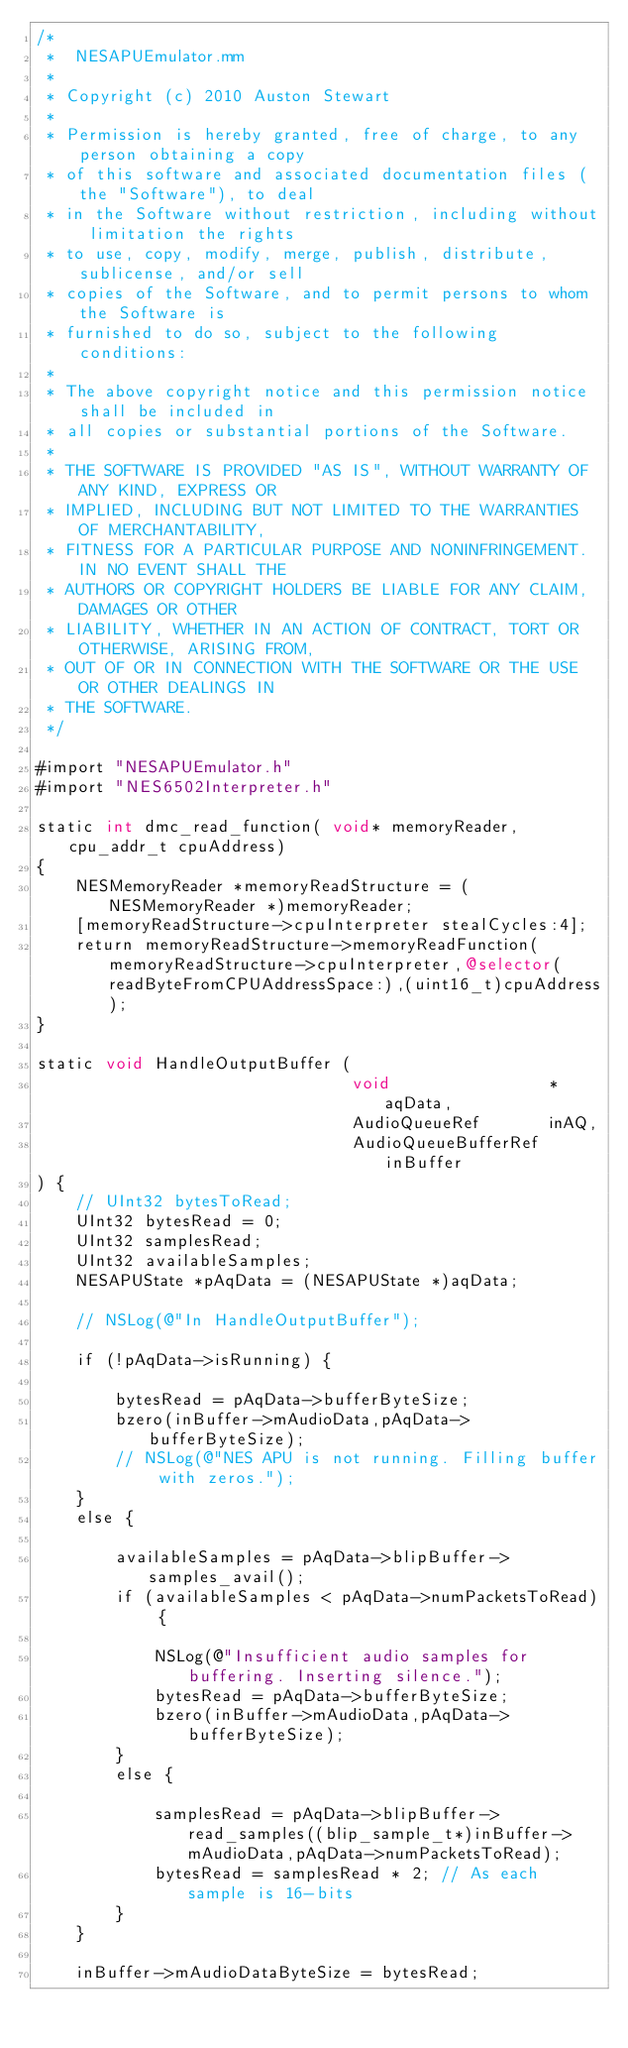<code> <loc_0><loc_0><loc_500><loc_500><_ObjectiveC_>/*
 *  NESAPUEmulator.mm
 *
 * Copyright (c) 2010 Auston Stewart
 *
 * Permission is hereby granted, free of charge, to any person obtaining a copy
 * of this software and associated documentation files (the "Software"), to deal
 * in the Software without restriction, including without limitation the rights
 * to use, copy, modify, merge, publish, distribute, sublicense, and/or sell
 * copies of the Software, and to permit persons to whom the Software is
 * furnished to do so, subject to the following conditions:
 * 
 * The above copyright notice and this permission notice shall be included in
 * all copies or substantial portions of the Software.
 * 
 * THE SOFTWARE IS PROVIDED "AS IS", WITHOUT WARRANTY OF ANY KIND, EXPRESS OR
 * IMPLIED, INCLUDING BUT NOT LIMITED TO THE WARRANTIES OF MERCHANTABILITY,
 * FITNESS FOR A PARTICULAR PURPOSE AND NONINFRINGEMENT. IN NO EVENT SHALL THE
 * AUTHORS OR COPYRIGHT HOLDERS BE LIABLE FOR ANY CLAIM, DAMAGES OR OTHER
 * LIABILITY, WHETHER IN AN ACTION OF CONTRACT, TORT OR OTHERWISE, ARISING FROM,
 * OUT OF OR IN CONNECTION WITH THE SOFTWARE OR THE USE OR OTHER DEALINGS IN
 * THE SOFTWARE.
 */

#import "NESAPUEmulator.h"
#import "NES6502Interpreter.h"

static int dmc_read_function( void* memoryReader, cpu_addr_t cpuAddress)
{
	NESMemoryReader *memoryReadStructure = (NESMemoryReader *)memoryReader;
	[memoryReadStructure->cpuInterpreter stealCycles:4];
	return memoryReadStructure->memoryReadFunction(memoryReadStructure->cpuInterpreter,@selector(readByteFromCPUAddressSpace:),(uint16_t)cpuAddress);
}

static void HandleOutputBuffer (
								void                *aqData,
								AudioQueueRef       inAQ,
								AudioQueueBufferRef inBuffer
) {
	// UInt32 bytesToRead;
	UInt32 bytesRead = 0;
	UInt32 samplesRead;
	UInt32 availableSamples;
    NESAPUState *pAqData = (NESAPUState *)aqData;
   
	// NSLog(@"In HandleOutputBuffer");
	
	if (!pAqData->isRunning) {
		
		bytesRead = pAqData->bufferByteSize;
		bzero(inBuffer->mAudioData,pAqData->bufferByteSize);
		// NSLog(@"NES APU is not running. Filling buffer with zeros.");	
	}
	else {
		
		availableSamples = pAqData->blipBuffer->samples_avail();
		if (availableSamples < pAqData->numPacketsToRead) {
			
			NSLog(@"Insufficient audio samples for buffering. Inserting silence.");
			bytesRead = pAqData->bufferByteSize;
			bzero(inBuffer->mAudioData,pAqData->bufferByteSize);
		}
		else {
			
			samplesRead = pAqData->blipBuffer->read_samples((blip_sample_t*)inBuffer->mAudioData,pAqData->numPacketsToRead);
			bytesRead = samplesRead * 2; // As each sample is 16-bits
		}
	}
			
	inBuffer->mAudioDataByteSize = bytesRead;</code> 